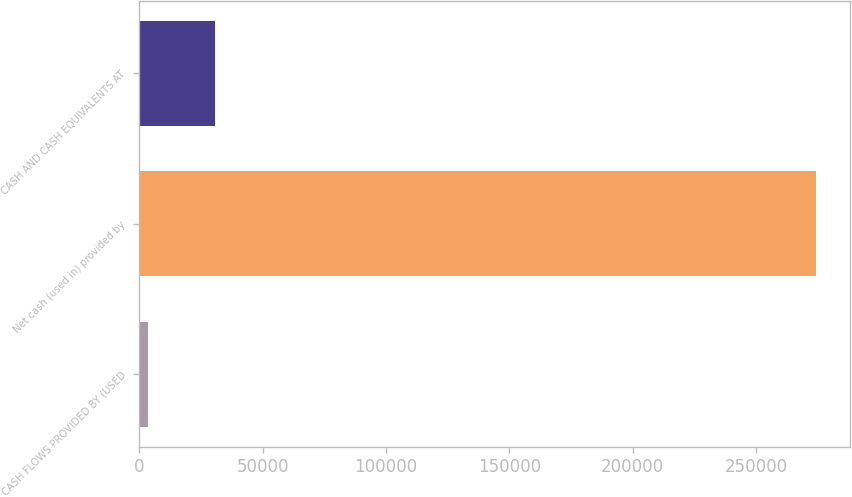Convert chart to OTSL. <chart><loc_0><loc_0><loc_500><loc_500><bar_chart><fcel>CASH FLOWS PROVIDED BY (USED<fcel>Net cash (used in) provided by<fcel>CASH AND CASH EQUIVALENTS AT<nl><fcel>3620<fcel>274420<fcel>30700<nl></chart> 